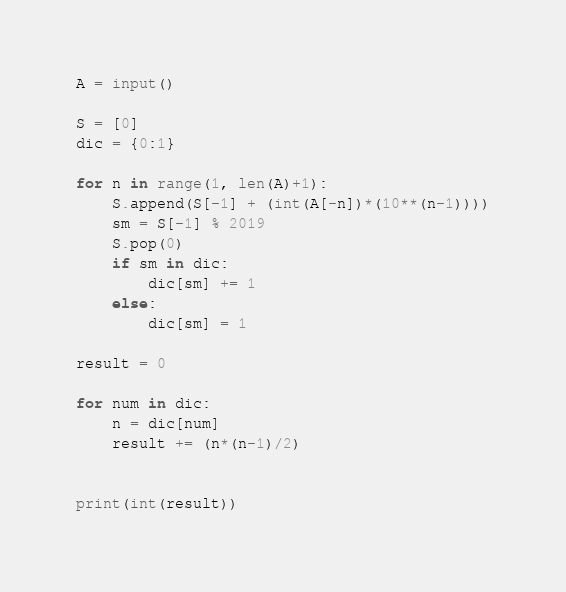<code> <loc_0><loc_0><loc_500><loc_500><_Python_>A = input()

S = [0]
dic = {0:1}

for n in range(1, len(A)+1):
    S.append(S[-1] + (int(A[-n])*(10**(n-1))))
    sm = S[-1] % 2019
    S.pop(0)
    if sm in dic:
        dic[sm] += 1
    else:
        dic[sm] = 1

result = 0

for num in dic:
    n = dic[num]
    result += (n*(n-1)/2)


print(int(result))
</code> 